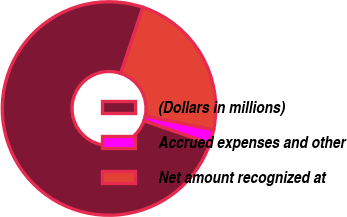Convert chart. <chart><loc_0><loc_0><loc_500><loc_500><pie_chart><fcel>(Dollars in millions)<fcel>Accrued expenses and other<fcel>Net amount recognized at<nl><fcel>74.85%<fcel>2.12%<fcel>23.03%<nl></chart> 